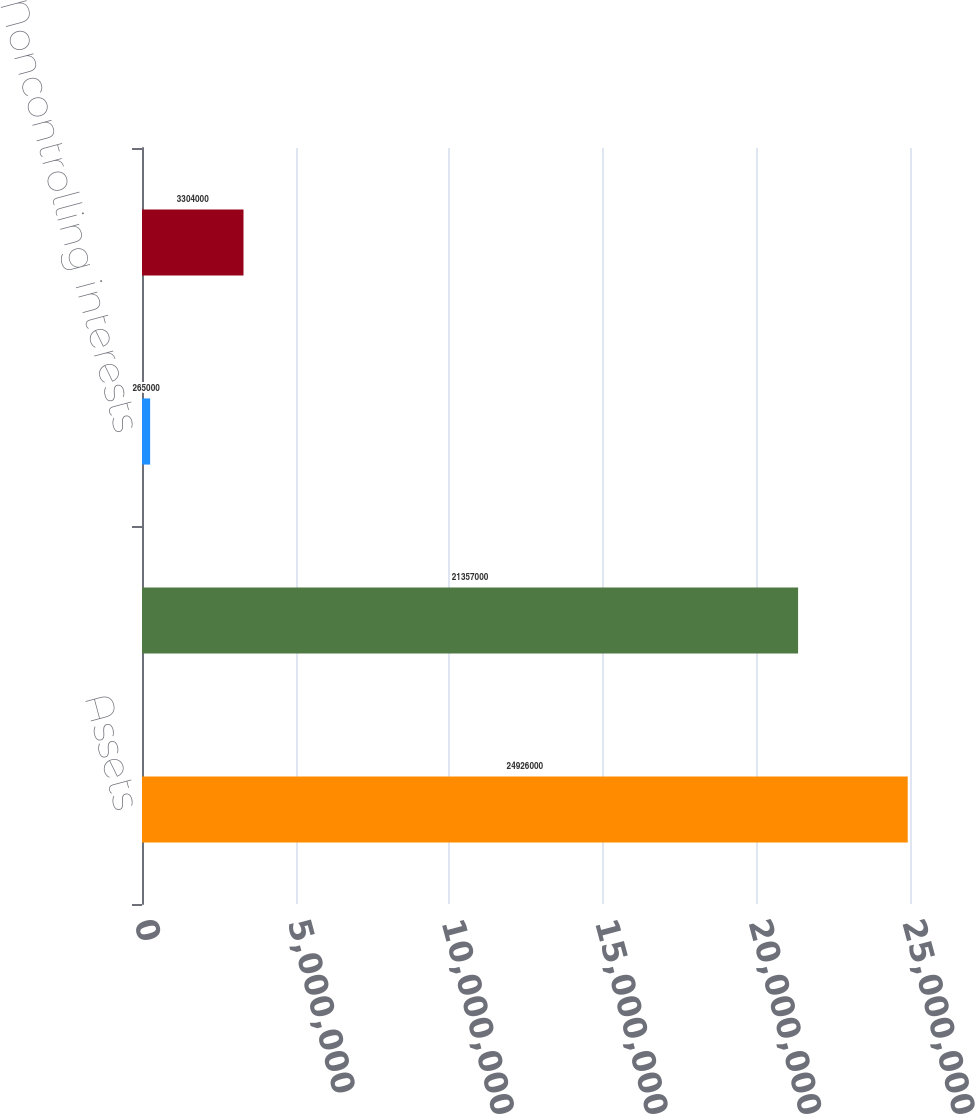Convert chart. <chart><loc_0><loc_0><loc_500><loc_500><bar_chart><fcel>Assets<fcel>Liabilities<fcel>Noncontrolling interests<fcel>Equity<nl><fcel>2.4926e+07<fcel>2.1357e+07<fcel>265000<fcel>3.304e+06<nl></chart> 